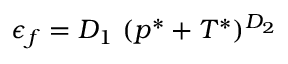<formula> <loc_0><loc_0><loc_500><loc_500>\epsilon _ { f } = D _ { 1 } ( p ^ { * } + T ^ { * } ) ^ { D _ { 2 } }</formula> 